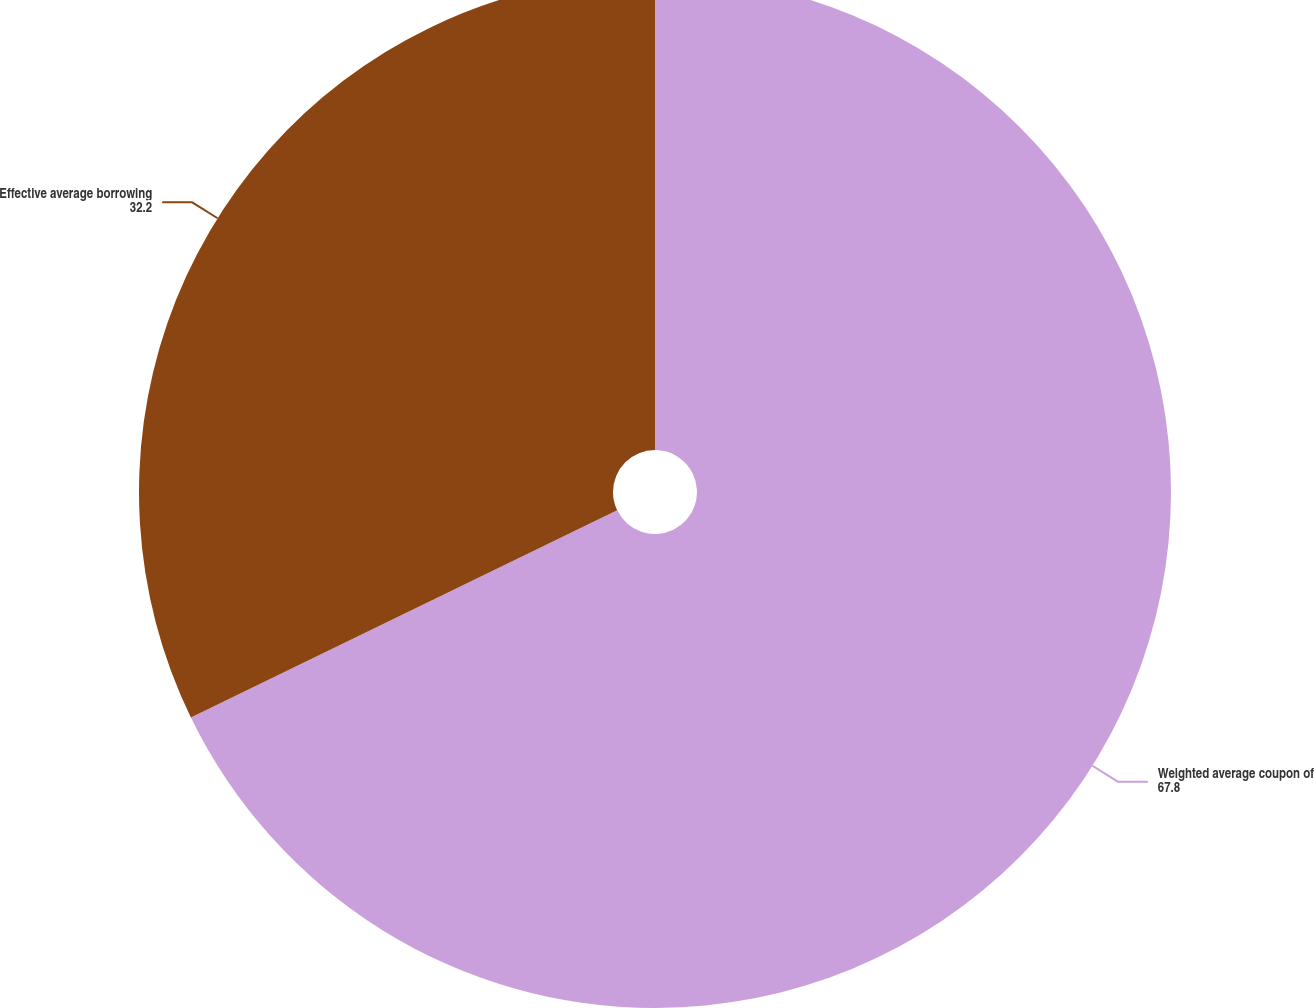<chart> <loc_0><loc_0><loc_500><loc_500><pie_chart><fcel>Weighted average coupon of<fcel>Effective average borrowing<nl><fcel>67.8%<fcel>32.2%<nl></chart> 